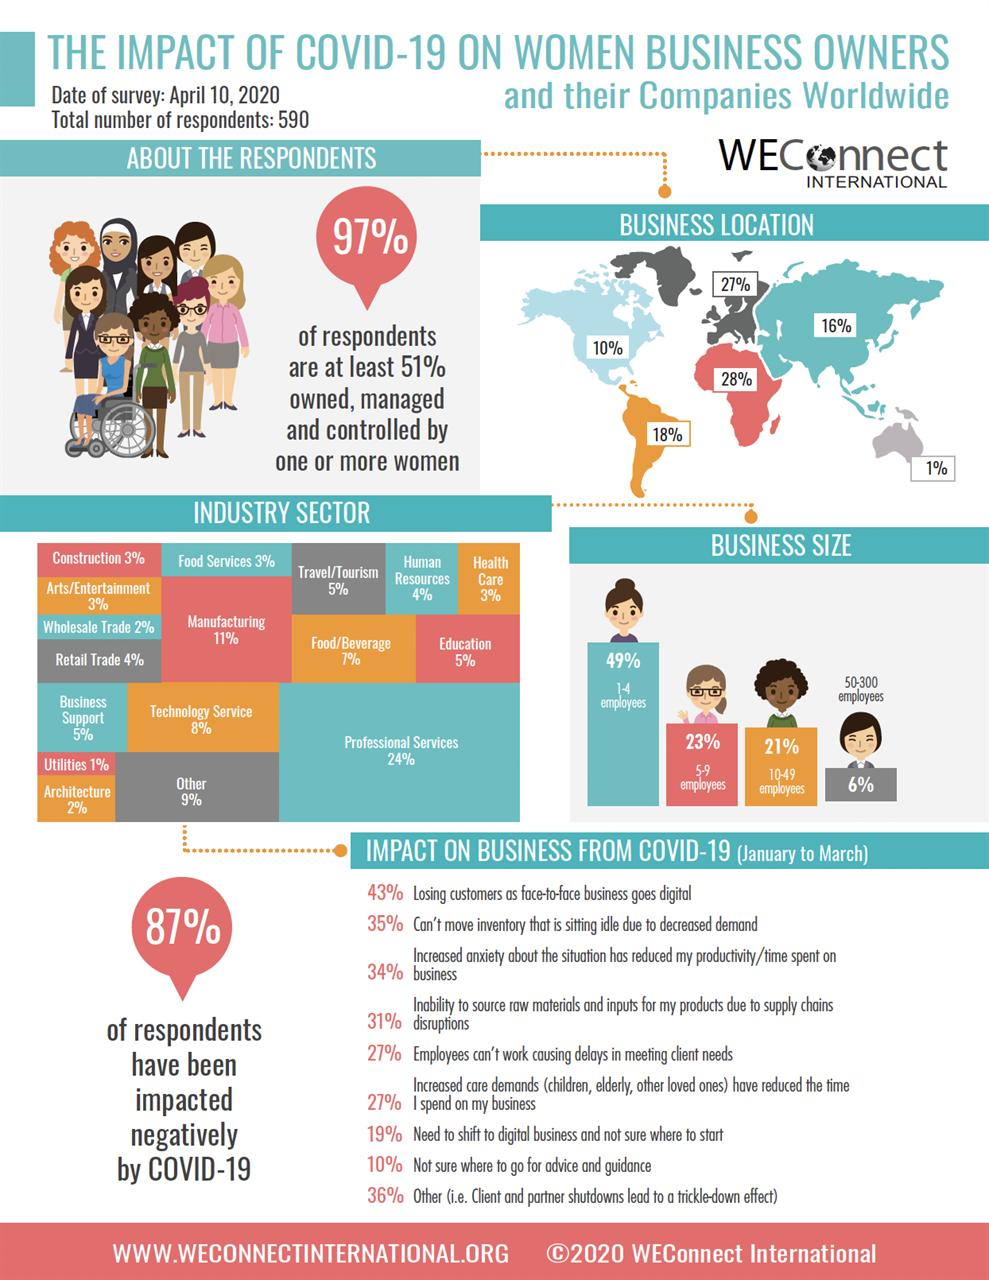Specify some key components in this picture. The percentage of respondents in the manufacturing sector is higher than the percentage of respondents in the education sector by 6%. It is estimated that 87% of women business owners have been negatively impacted by COVID-19. According to the survey, only 3% of respondents are employed in the health care industry. According to a recent survey, approximately 49% of businesses have 1-4 employees. In the United States, six percent of women-owned businesses employ more than 50 workers. 